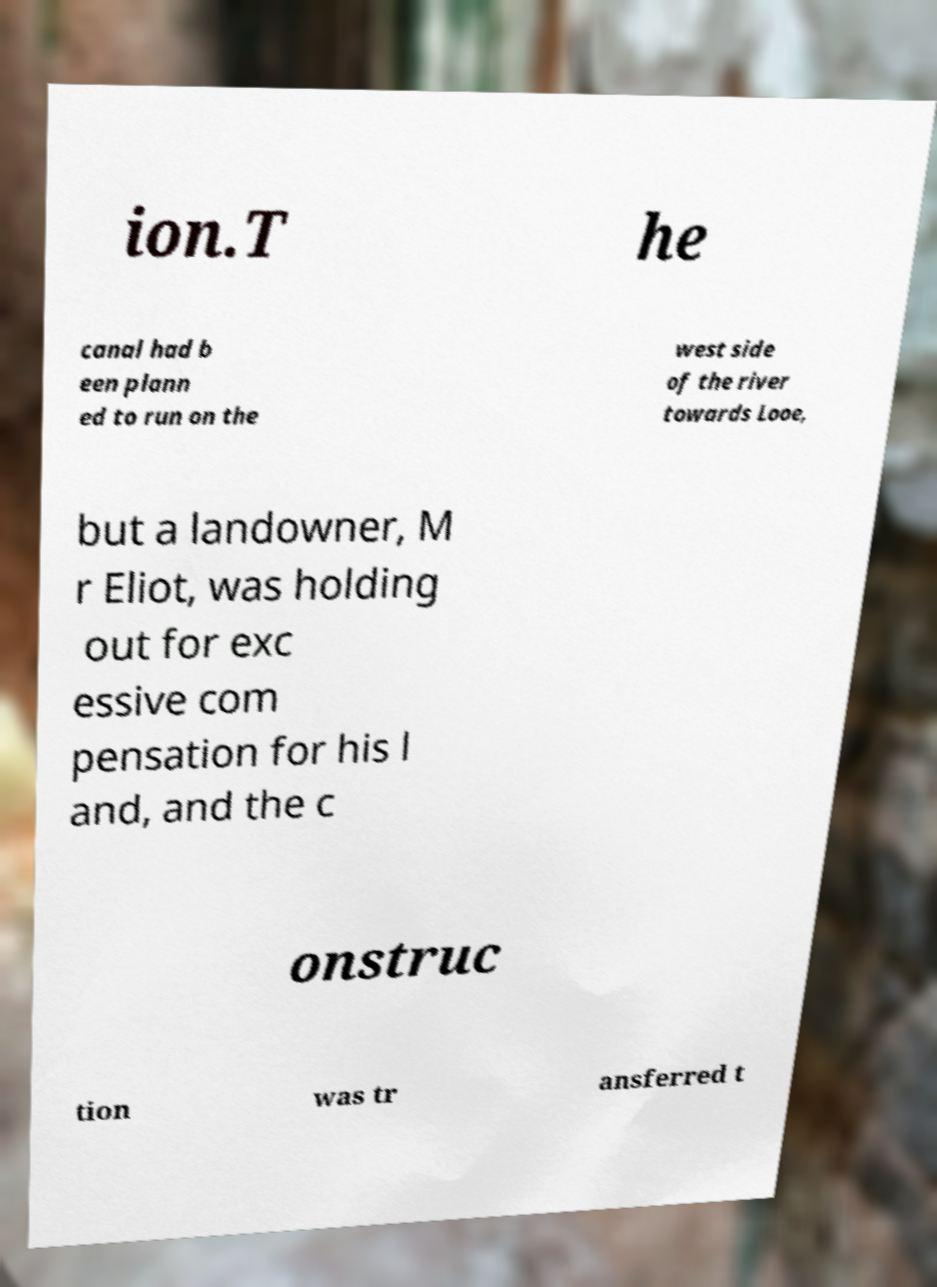Could you extract and type out the text from this image? ion.T he canal had b een plann ed to run on the west side of the river towards Looe, but a landowner, M r Eliot, was holding out for exc essive com pensation for his l and, and the c onstruc tion was tr ansferred t 